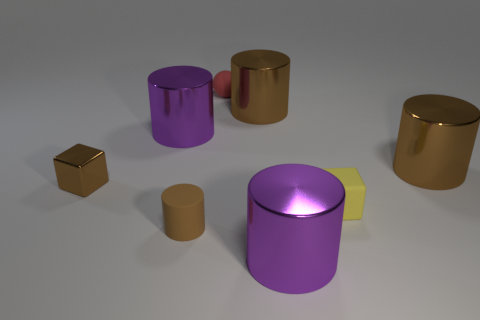What is the shape of the large metal thing in front of the brown block?
Give a very brief answer. Cylinder. Are the small red object and the tiny brown cylinder made of the same material?
Your answer should be compact. Yes. Are there any other things that are the same material as the yellow cube?
Your response must be concise. Yes. What material is the tiny brown thing that is the same shape as the small yellow object?
Offer a terse response. Metal. Are there fewer blocks on the right side of the red rubber ball than large metal objects?
Provide a succinct answer. Yes. How many objects are to the left of the small rubber block?
Offer a very short reply. 6. There is a large purple metal object on the left side of the rubber cylinder; does it have the same shape as the matte object to the left of the small red matte ball?
Ensure brevity in your answer.  Yes. What is the shape of the matte thing that is right of the tiny brown matte cylinder and in front of the small red thing?
Provide a short and direct response. Cube. What is the size of the red object that is made of the same material as the tiny yellow object?
Your answer should be compact. Small. Is the number of blocks less than the number of small brown cubes?
Offer a terse response. No. 